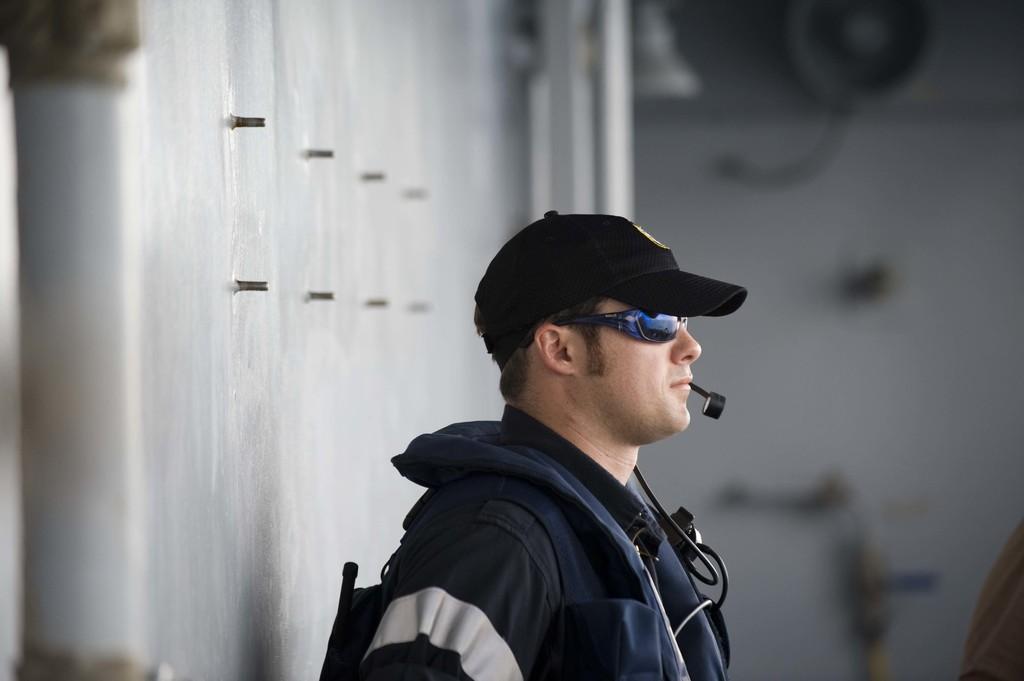In one or two sentences, can you explain what this image depicts? In this image we can see a man standing and a microphone attached to him and there is a wall in the background. 